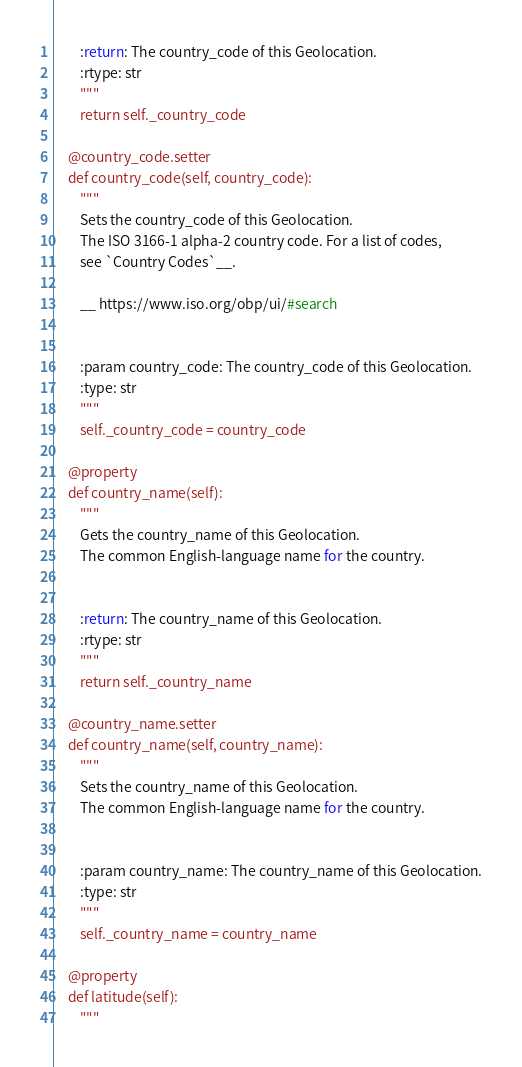<code> <loc_0><loc_0><loc_500><loc_500><_Python_>        :return: The country_code of this Geolocation.
        :rtype: str
        """
        return self._country_code

    @country_code.setter
    def country_code(self, country_code):
        """
        Sets the country_code of this Geolocation.
        The ISO 3166-1 alpha-2 country code. For a list of codes,
        see `Country Codes`__.

        __ https://www.iso.org/obp/ui/#search


        :param country_code: The country_code of this Geolocation.
        :type: str
        """
        self._country_code = country_code

    @property
    def country_name(self):
        """
        Gets the country_name of this Geolocation.
        The common English-language name for the country.


        :return: The country_name of this Geolocation.
        :rtype: str
        """
        return self._country_name

    @country_name.setter
    def country_name(self, country_name):
        """
        Sets the country_name of this Geolocation.
        The common English-language name for the country.


        :param country_name: The country_name of this Geolocation.
        :type: str
        """
        self._country_name = country_name

    @property
    def latitude(self):
        """</code> 